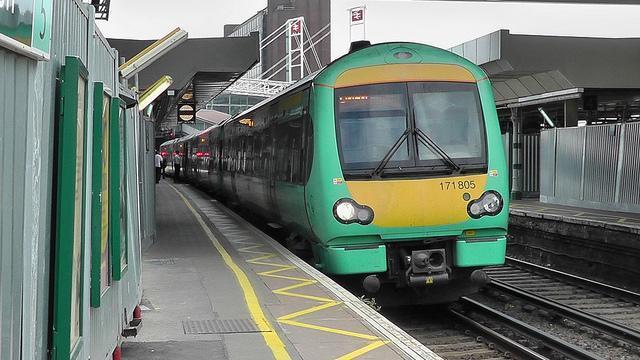How many bicycles are on the other side of the street?
Give a very brief answer. 0. 